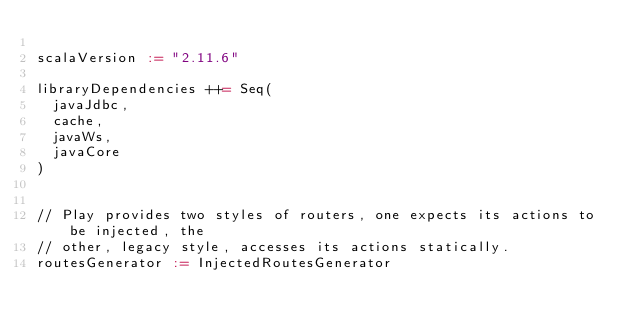Convert code to text. <code><loc_0><loc_0><loc_500><loc_500><_Scala_>
scalaVersion := "2.11.6"

libraryDependencies ++= Seq(
  javaJdbc,
  cache,
  javaWs,
  javaCore
)


// Play provides two styles of routers, one expects its actions to be injected, the
// other, legacy style, accesses its actions statically.
routesGenerator := InjectedRoutesGenerator
</code> 